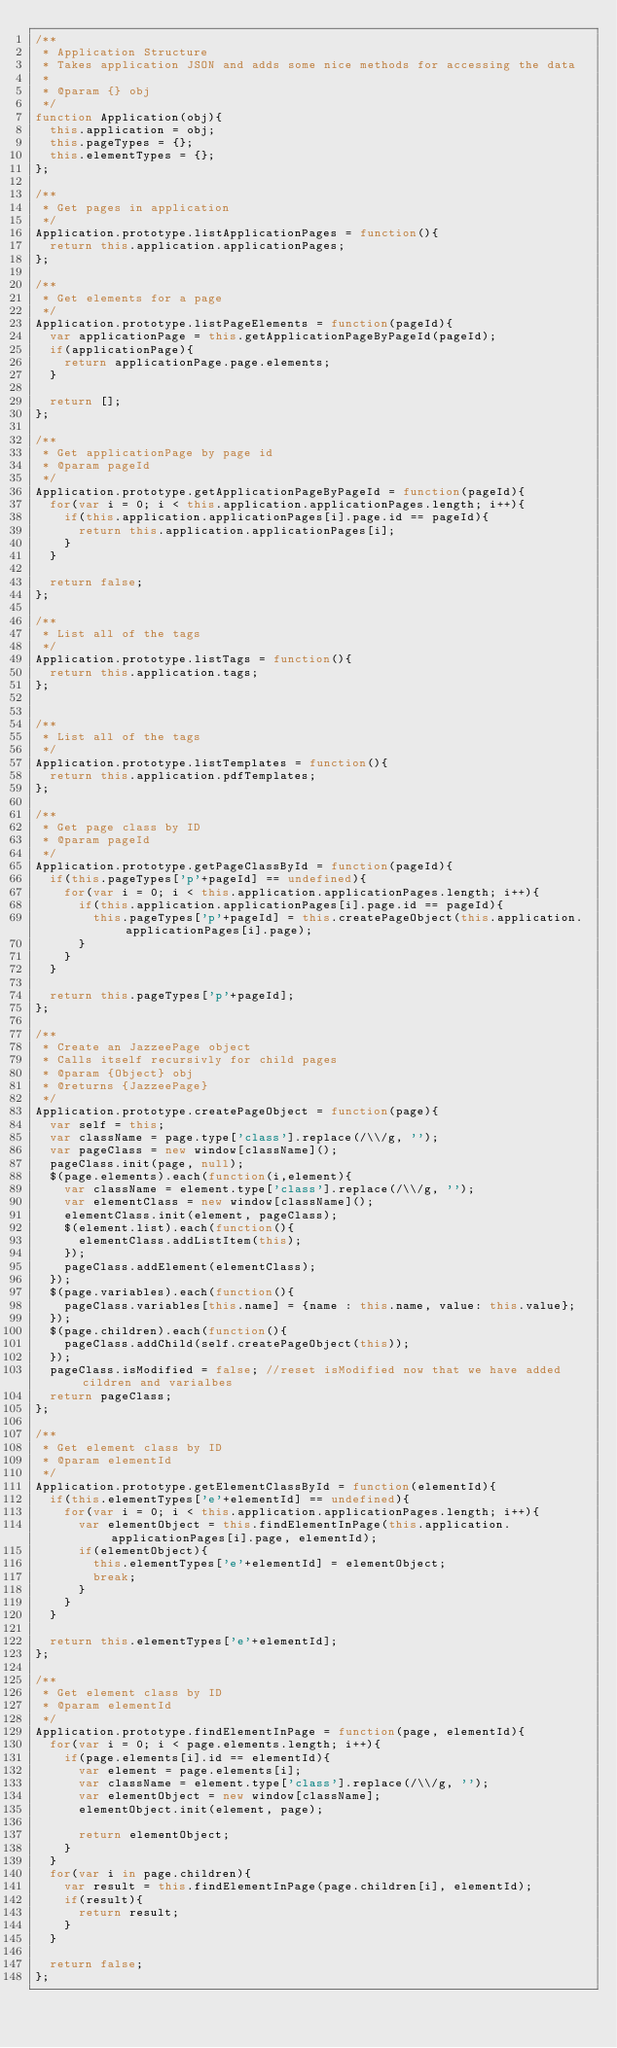<code> <loc_0><loc_0><loc_500><loc_500><_JavaScript_>/**
 * Application Structure
 * Takes application JSON and adds some nice methods for accessing the data
 * 
 * @param {} obj
 */
function Application(obj){
  this.application = obj;
  this.pageTypes = {};
  this.elementTypes = {};
};

/**
 * Get pages in application
 */
Application.prototype.listApplicationPages = function(){
  return this.application.applicationPages;
};

/**
 * Get elements for a page
 */
Application.prototype.listPageElements = function(pageId){
  var applicationPage = this.getApplicationPageByPageId(pageId);
  if(applicationPage){
    return applicationPage.page.elements;
  }

  return [];
};

/**
 * Get applicationPage by page id
 * @param pageId
 */
Application.prototype.getApplicationPageByPageId = function(pageId){
  for(var i = 0; i < this.application.applicationPages.length; i++){
    if(this.application.applicationPages[i].page.id == pageId){
      return this.application.applicationPages[i];
    }
  }

  return false;
};

/**
 * List all of the tags
 */
Application.prototype.listTags = function(){
  return this.application.tags;
};


/**
 * List all of the tags
 */
Application.prototype.listTemplates = function(){
  return this.application.pdfTemplates;
};

/**
 * Get page class by ID
 * @param pageId
 */
Application.prototype.getPageClassById = function(pageId){
  if(this.pageTypes['p'+pageId] == undefined){
    for(var i = 0; i < this.application.applicationPages.length; i++){
      if(this.application.applicationPages[i].page.id == pageId){
        this.pageTypes['p'+pageId] = this.createPageObject(this.application.applicationPages[i].page);
      }
    }
  }

  return this.pageTypes['p'+pageId];
};

/**
 * Create an JazzeePage object
 * Calls itself recursivly for child pages
 * @param {Object} obj
 * @returns {JazzeePage}
 */
Application.prototype.createPageObject = function(page){
  var self = this;
  var className = page.type['class'].replace(/\\/g, '');
  var pageClass = new window[className]();
  pageClass.init(page, null);
  $(page.elements).each(function(i,element){
    var className = element.type['class'].replace(/\\/g, '');
    var elementClass = new window[className]();
    elementClass.init(element, pageClass);
    $(element.list).each(function(){
      elementClass.addListItem(this);
    });
    pageClass.addElement(elementClass);
  });
  $(page.variables).each(function(){
    pageClass.variables[this.name] = {name : this.name, value: this.value};
  });
  $(page.children).each(function(){
    pageClass.addChild(self.createPageObject(this));
  });
  pageClass.isModified = false; //reset isModified now that we have added cildren and varialbes
  return pageClass;
};

/**
 * Get element class by ID
 * @param elementId
 */
Application.prototype.getElementClassById = function(elementId){
  if(this.elementTypes['e'+elementId] == undefined){
    for(var i = 0; i < this.application.applicationPages.length; i++){
      var elementObject = this.findElementInPage(this.application.applicationPages[i].page, elementId);
      if(elementObject){
        this.elementTypes['e'+elementId] = elementObject;
        break;
      }
    }
  }

  return this.elementTypes['e'+elementId];
};

/**
 * Get element class by ID
 * @param elementId
 */
Application.prototype.findElementInPage = function(page, elementId){
  for(var i = 0; i < page.elements.length; i++){
    if(page.elements[i].id == elementId){
      var element = page.elements[i];
      var className = element.type['class'].replace(/\\/g, '');
      var elementObject = new window[className];
      elementObject.init(element, page);

      return elementObject;
    }
  }
  for(var i in page.children){
    var result = this.findElementInPage(page.children[i], elementId);
    if(result){
      return result;
    }
  }

  return false;
};</code> 